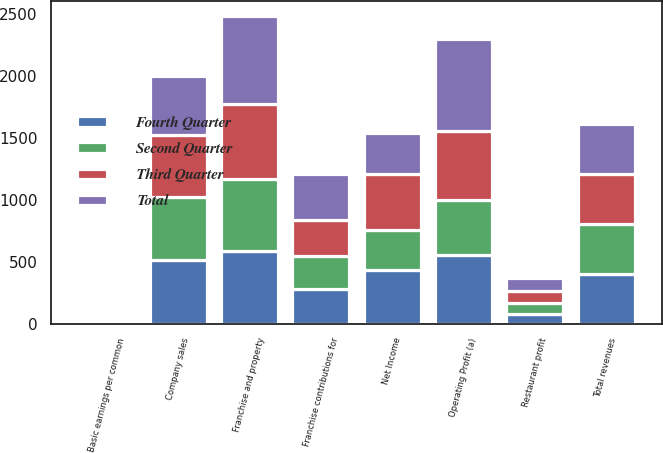<chart> <loc_0><loc_0><loc_500><loc_500><stacked_bar_chart><ecel><fcel>Company sales<fcel>Franchise and property<fcel>Franchise contributions for<fcel>Total revenues<fcel>Restaurant profit<fcel>Operating Profit (a)<fcel>Net Income<fcel>Basic earnings per common<nl><fcel>Fourth Quarter<fcel>512<fcel>584<fcel>275<fcel>402.5<fcel>74<fcel>553<fcel>433<fcel>1.3<nl><fcel>Second Quarter<fcel>512<fcel>584<fcel>272<fcel>402.5<fcel>91<fcel>449<fcel>321<fcel>0.99<nl><fcel>Third Quarter<fcel>499<fcel>605<fcel>287<fcel>402.5<fcel>100<fcel>553<fcel>454<fcel>1.43<nl><fcel>Total<fcel>477<fcel>709<fcel>372<fcel>402.5<fcel>101<fcel>741<fcel>334<fcel>1.07<nl></chart> 